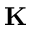<formula> <loc_0><loc_0><loc_500><loc_500>K</formula> 